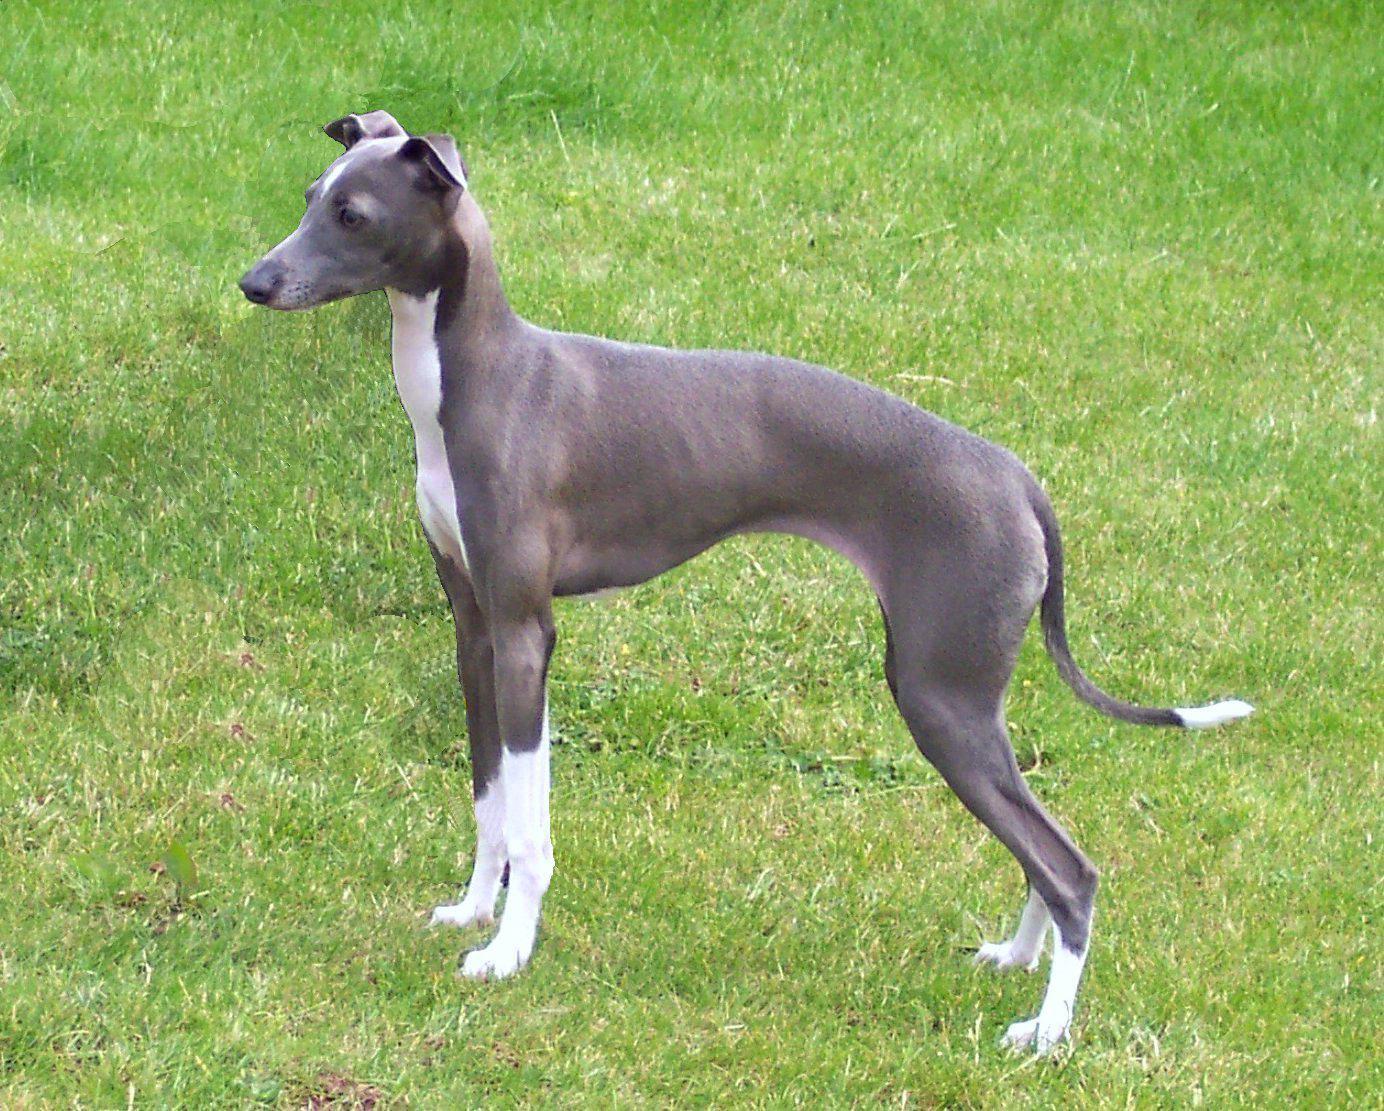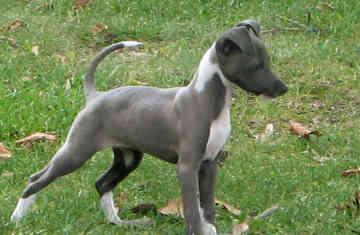The first image is the image on the left, the second image is the image on the right. For the images shown, is this caption "There is a dog with its head to the left and its tail to the right." true? Answer yes or no. Yes. 